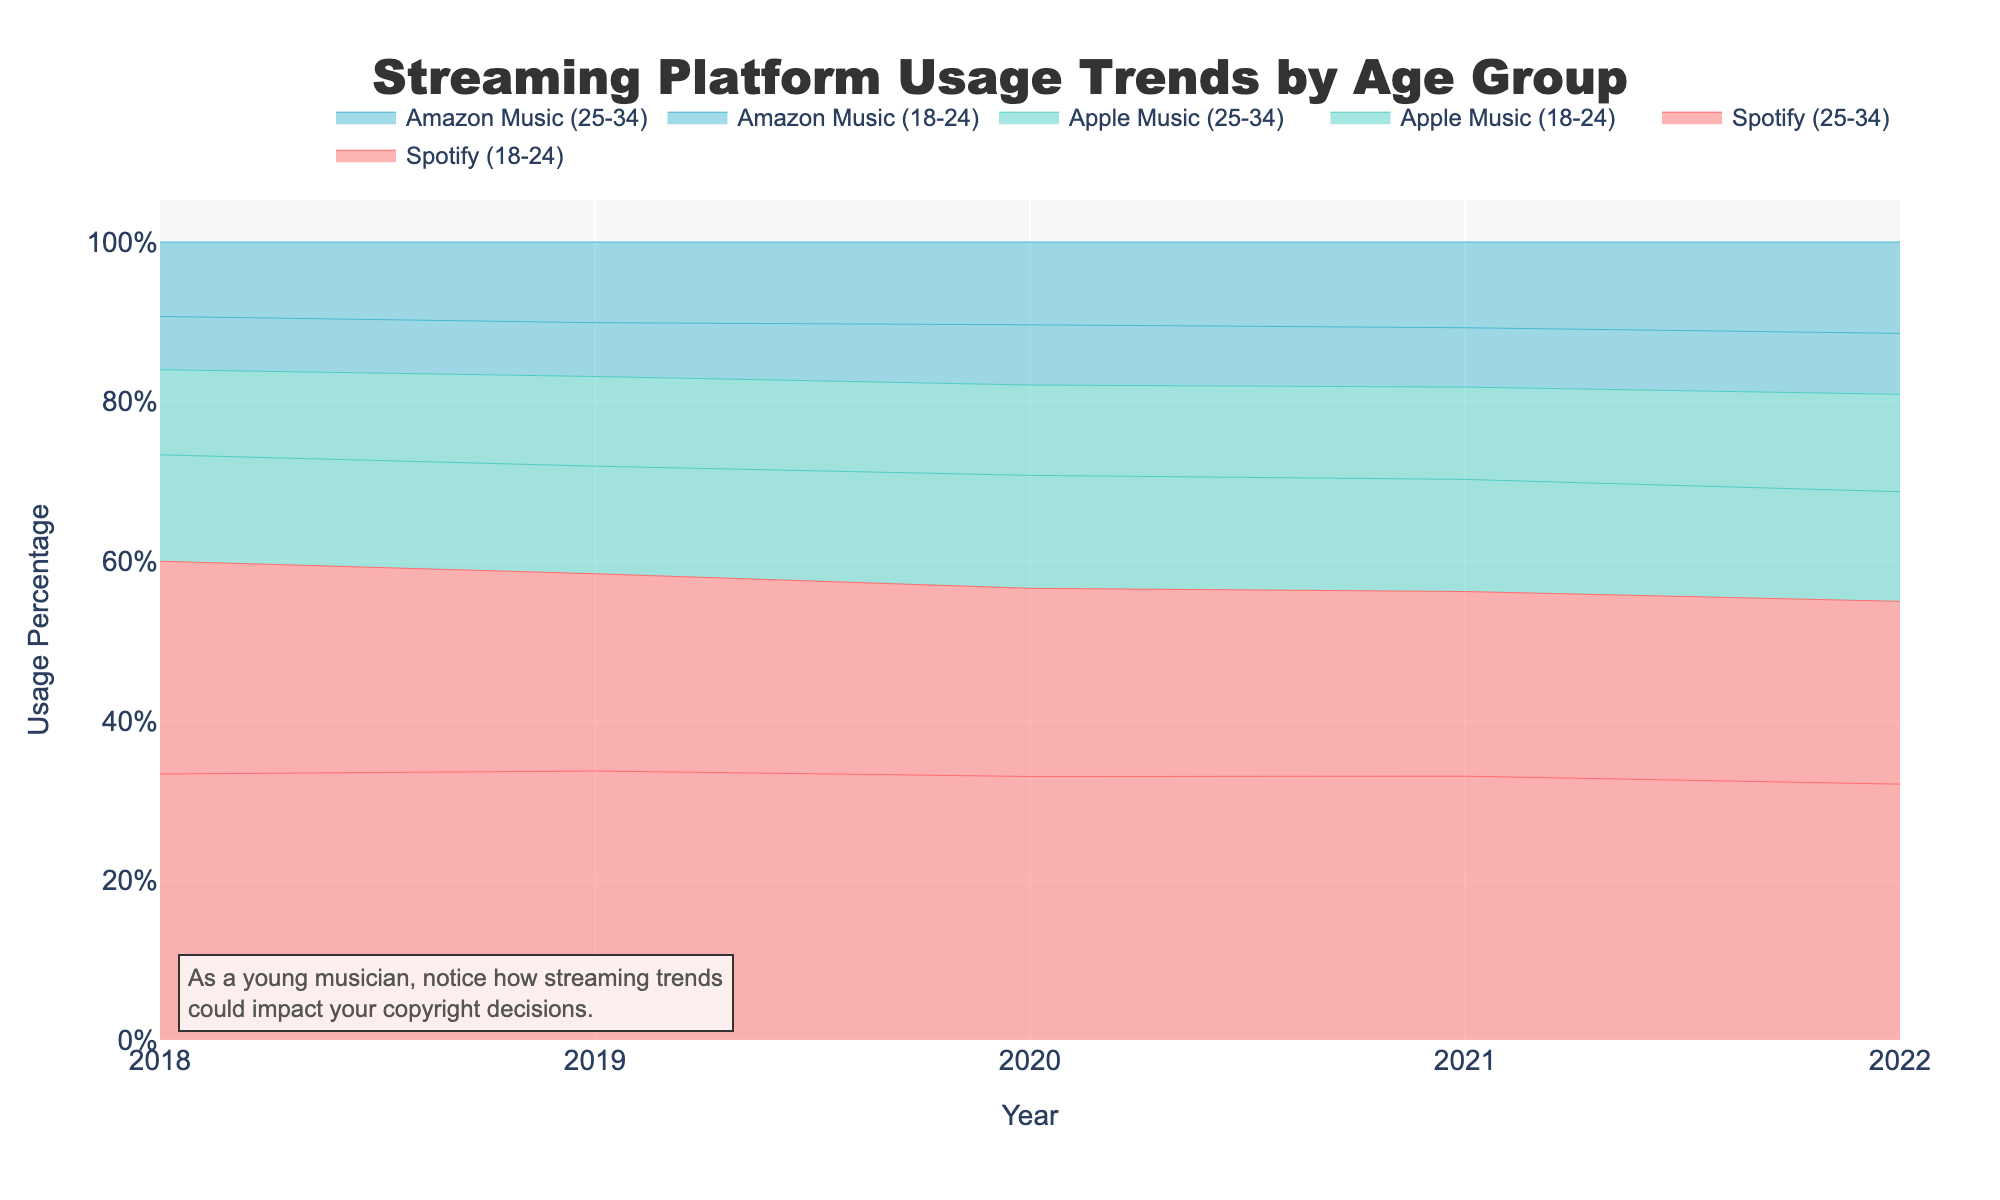What is the title of the figure? The title of the figure is prominently displayed at the top. According to the provided code, the title is 'Streaming Platform Usage Trends by Age Group'.
Answer: Streaming Platform Usage Trends by Age Group Which age group shows the highest Spotify usage in 2022? By looking at the 2022 data points for Spotify, we observe that the 18-24 age group has a higher percentage usage compared to the 25-34 age group.
Answer: 18-24 How has Apple Music usage changed for the 25-34 age group from 2018 to 2022? To find this, observe the Apple Music line for the 25-34 age group. In 2018, the usage percentage is 8%, and in 2022, it is 16%.
Answer: Increased by 8% Compare the trend of Spotify usage between the 18-24 and 25-34 age groups from 2018 to 2022. Look at the lines representing Spotify for both age groups. Both show an increasing trend, but the 18-24 age group has a steeper incline and higher overall percentages than the 25-34 age group.
Answer: 18-24 has a steeper incline and higher percentages Which platform had the lowest usage among 18-24-year-olds in 2018? Identify the data points for each platform among the 18-24 age group in 2018. The lowest percentage usage is seen in Amazon Music with 5%.
Answer: Amazon Music What is the combined Spotify usage for both age groups in 2019? Sum the usage percentages of both age groups for Spotify in 2019. For 18-24, it is 30%, and for 25-34, it is 22%. The combined usage is 30% + 22%.
Answer: 52% Which platform shows a larger increase in usage for the 25-34 age group between 2018 and 2022, Spotify or Amazon Music? Compare the increase in usage percentages for Spotify and Amazon Music between 2018 and 2022 in the 25-34 age group. Spotify increases from 20% to 30% (10%), while Amazon Music increases from 7% to 15% (8%).
Answer: Spotify (10%) Has the usage percentage for Apple Music increased or decreased among the 18-24 age group between 2018 and 2022, and by how much? Look at the Apple Music line for the 18-24 age group. In 2018, the usage percentage is 10%, and in 2022, it is 18%.
Answer: Increased by 8% Which age group shows a consistent increase in usage for all three platforms from 2018 to 2022? Examine the usage trends for both age groups across all three platforms. Both age groups show increasing trends, making the answer applicable to both.
Answer: Both age groups What annotation is added for the young musician in the figure? An annotation at the bottom left of the figure notes, "As a young musician, notice how streaming trends could impact your copyright decisions."
Answer: "As a young musician, notice how streaming trends could impact your copyright decisions." 